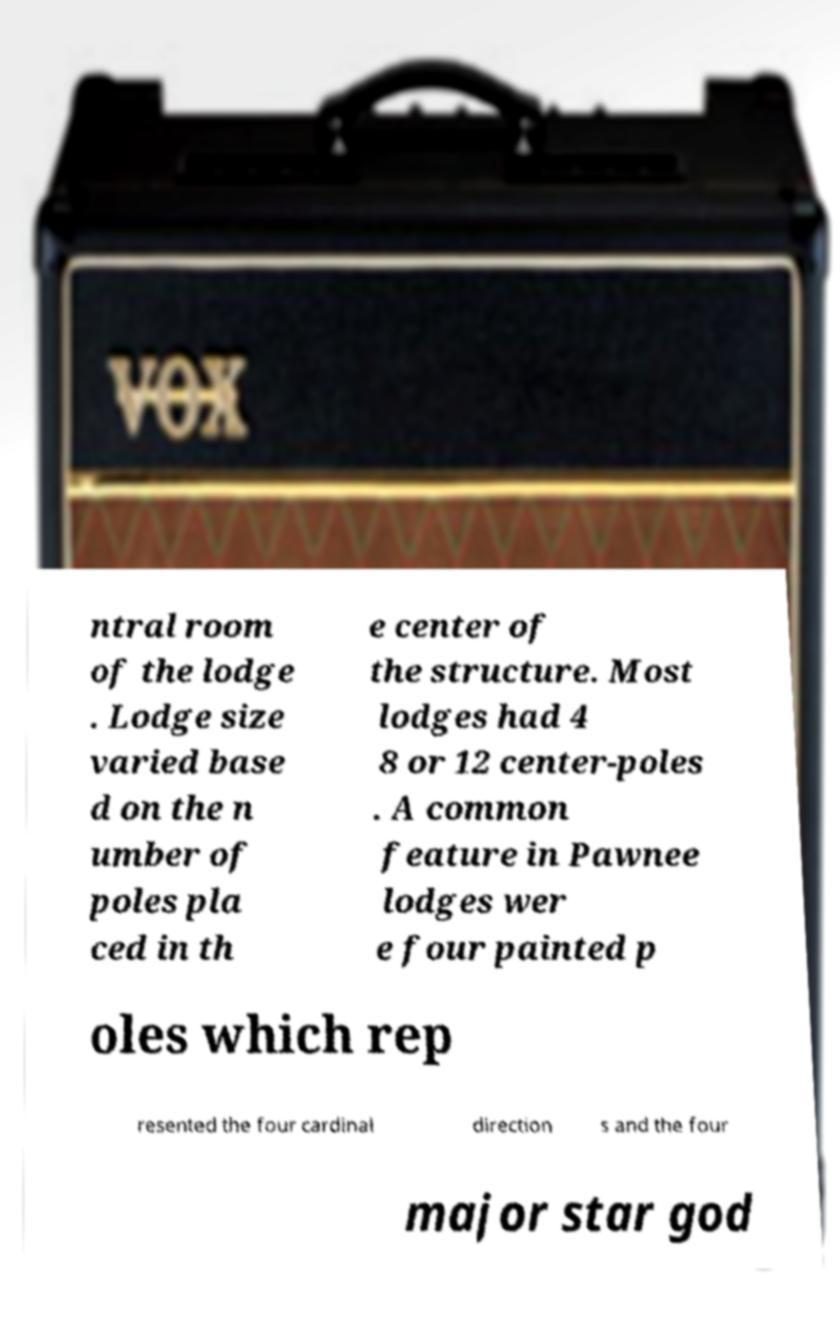Can you read and provide the text displayed in the image?This photo seems to have some interesting text. Can you extract and type it out for me? ntral room of the lodge . Lodge size varied base d on the n umber of poles pla ced in th e center of the structure. Most lodges had 4 8 or 12 center-poles . A common feature in Pawnee lodges wer e four painted p oles which rep resented the four cardinal direction s and the four major star god 